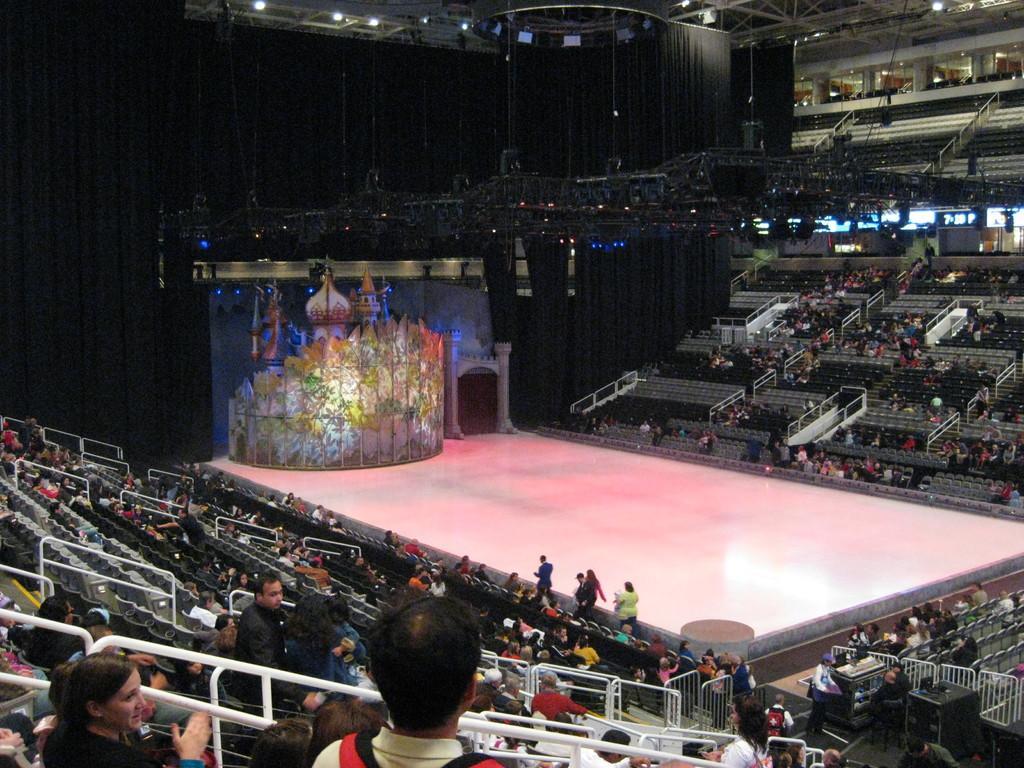Please provide a concise description of this image. In this image I can see number of people where few are standing and few are sitting on chairs. I can also see stage over here and in background I can see few lights. 